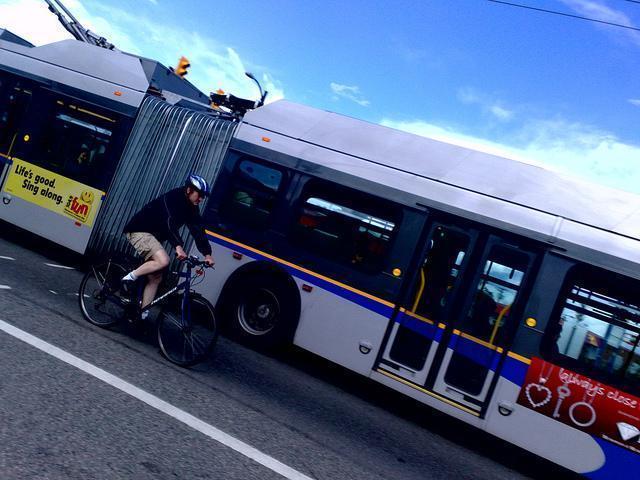What kind of store is most likely responsible for the red advertisement on the side of the bus?
Answer the question by selecting the correct answer among the 4 following choices.
Options: Electronics, sporting, office supplies, jewelry. Jewelry. 